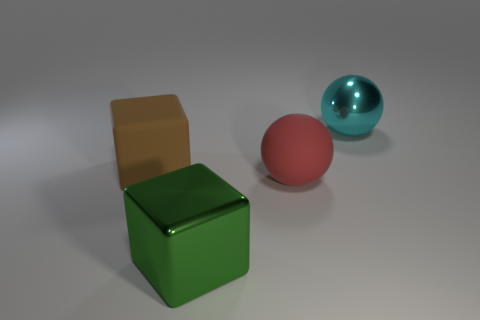How many objects are big metal things in front of the large cyan shiny ball or big yellow rubber balls?
Keep it short and to the point. 1. There is a brown thing that is made of the same material as the large red sphere; what is its size?
Give a very brief answer. Large. How many tiny objects are either shiny things or green shiny cubes?
Your answer should be very brief. 0. Are there any big balls made of the same material as the large green block?
Your answer should be very brief. Yes. There is a big block that is behind the red rubber object; what is its material?
Your answer should be very brief. Rubber. The metallic object that is the same size as the cyan metallic sphere is what color?
Give a very brief answer. Green. What number of other things are the same shape as the large cyan thing?
Offer a very short reply. 1. There is a rubber object that is to the right of the big brown rubber object; how big is it?
Offer a very short reply. Large. There is a large thing that is in front of the large red matte sphere; what number of large rubber objects are on the left side of it?
Your answer should be compact. 1. What number of other things are there of the same size as the metallic ball?
Ensure brevity in your answer.  3. 